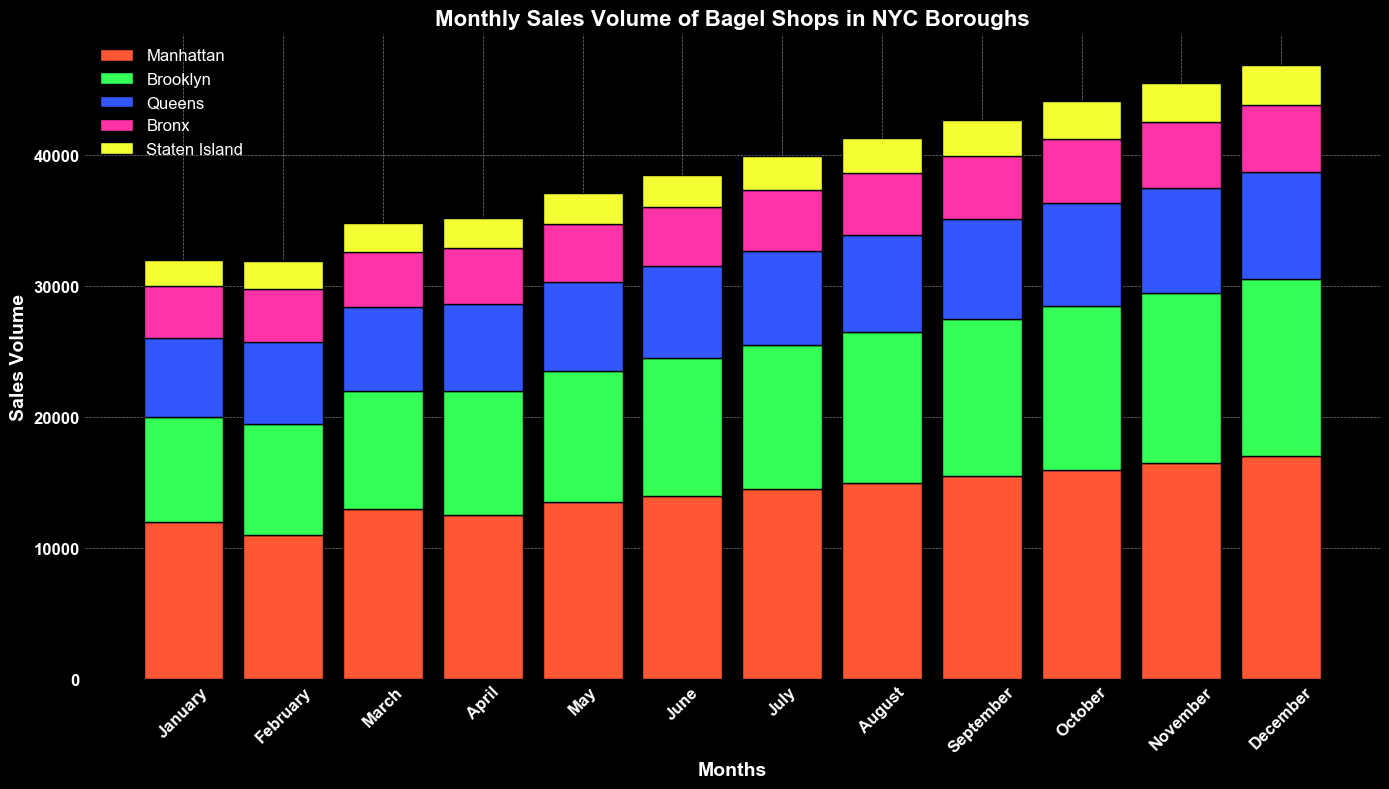Which borough had the highest sales volume in November? Look at the November sales volume bars for each borough and identify the tallest bar.
Answer: Manhattan How many total bagels were sold across all boroughs in March? Sum the sales volumes for all boroughs in March: 13000 (Manhattan) + 9000 (Brooklyn) + 6400 (Queens) + 4200 (Bronx) + 2200 (Staten Island) = 34800
Answer: 34800 Is the sales volume in Brooklyn higher in June or July? Compare the height of the bars for Brooklyn in June and July. The bar for July is higher.
Answer: July Which borough showed the largest increase in sales volume from January to December? Calculate the difference between January and December sales volumes for each borough and identify the largest increase: Manhattan (5000), Brooklyn (5500), Queens (2200), Bronx (1100), Staten Island (1100).
Answer: Brooklyn What is the average sales volume for Manhattan in the first quarter (January-March)? Sum the sales volumes for Manhattan in January, February, and March and divide by 3: (12000 + 11000 + 13000) / 3 = 12000
Answer: 12000 Does Queens ever exceed 8000 in monthly sales volume? Check each bar for Queens to see if it ever reaches or exceeds 8000. Yes, it exceeds 8000 in November and December.
Answer: Yes Which two consecutive months in Manhattan show the highest increase in sales volume? Find the month-to-month differences in sales volumes in Manhattan and identify the highest: August-September (500).
Answer: August to September In August, what is the difference in sales volume between the borough with the highest sales and the borough with the lowest sales? Identify the highest sales volume (Manhattan, 15000) and the lowest (Staten Island, 2700) in August. Subtract the lowest value from the highest: 15000 - 2700 = 12300
Answer: 12300 What is the cumulative sales volume for the Bronx over the entire year? Sum the sales volumes for the Bronx across all months: 4000 + 4100 + 4200 + 4300 + 4400 + 4500 + 4600 + 4700 + 4800 + 4900 + 5000 + 5100 = 53600
Answer: 53600 Compare the sales volume trends over the year for Queens and Staten Island. Which borough shows a steadier increase? Analyze the month-to-month changes for both areas. Queens shows a consistent increase each month, whereas Staten Island has a lower but steady increase.
Answer: Queens 